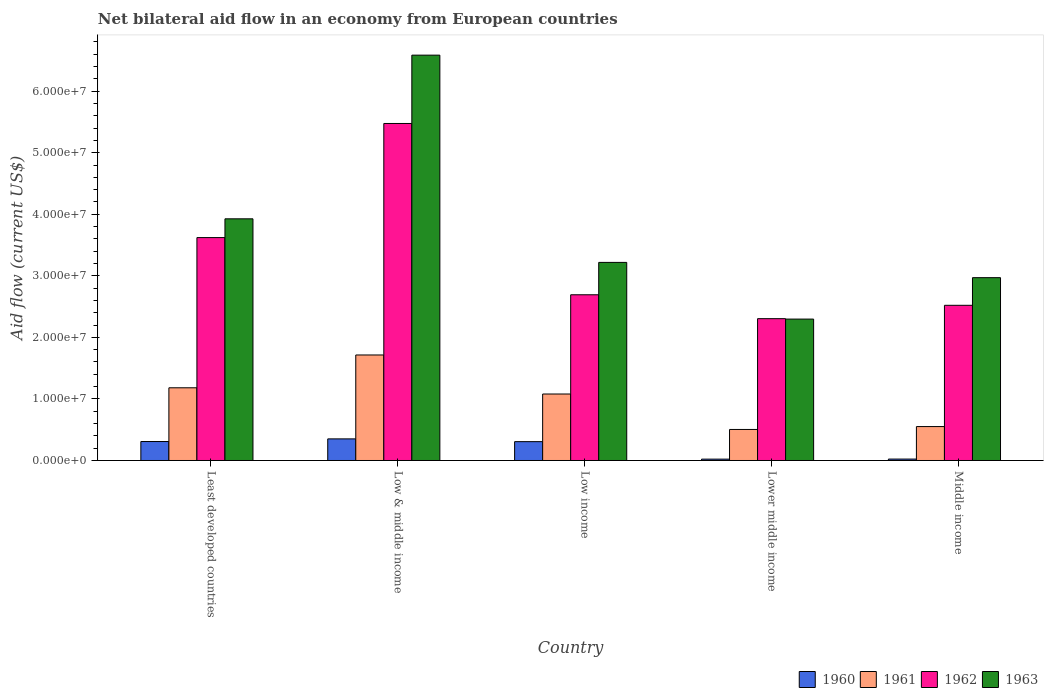Are the number of bars on each tick of the X-axis equal?
Ensure brevity in your answer.  Yes. How many bars are there on the 2nd tick from the right?
Your answer should be very brief. 4. In how many cases, is the number of bars for a given country not equal to the number of legend labels?
Ensure brevity in your answer.  0. What is the net bilateral aid flow in 1960 in Middle income?
Your answer should be compact. 2.30e+05. Across all countries, what is the maximum net bilateral aid flow in 1961?
Your response must be concise. 1.71e+07. Across all countries, what is the minimum net bilateral aid flow in 1962?
Your response must be concise. 2.30e+07. In which country was the net bilateral aid flow in 1960 maximum?
Give a very brief answer. Low & middle income. In which country was the net bilateral aid flow in 1962 minimum?
Keep it short and to the point. Lower middle income. What is the total net bilateral aid flow in 1960 in the graph?
Keep it short and to the point. 1.01e+07. What is the difference between the net bilateral aid flow in 1962 in Low income and the net bilateral aid flow in 1960 in Least developed countries?
Make the answer very short. 2.38e+07. What is the average net bilateral aid flow in 1961 per country?
Your response must be concise. 1.01e+07. What is the difference between the net bilateral aid flow of/in 1963 and net bilateral aid flow of/in 1960 in Low income?
Ensure brevity in your answer.  2.91e+07. In how many countries, is the net bilateral aid flow in 1961 greater than 2000000 US$?
Make the answer very short. 5. What is the ratio of the net bilateral aid flow in 1962 in Low & middle income to that in Lower middle income?
Your answer should be compact. 2.38. Is the net bilateral aid flow in 1960 in Least developed countries less than that in Middle income?
Your answer should be compact. No. Is the difference between the net bilateral aid flow in 1963 in Low income and Lower middle income greater than the difference between the net bilateral aid flow in 1960 in Low income and Lower middle income?
Keep it short and to the point. Yes. What is the difference between the highest and the second highest net bilateral aid flow in 1962?
Make the answer very short. 2.78e+07. What is the difference between the highest and the lowest net bilateral aid flow in 1963?
Keep it short and to the point. 4.29e+07. Is the sum of the net bilateral aid flow in 1960 in Least developed countries and Middle income greater than the maximum net bilateral aid flow in 1962 across all countries?
Ensure brevity in your answer.  No. Is it the case that in every country, the sum of the net bilateral aid flow in 1960 and net bilateral aid flow in 1963 is greater than the sum of net bilateral aid flow in 1961 and net bilateral aid flow in 1962?
Ensure brevity in your answer.  Yes. What does the 3rd bar from the left in Least developed countries represents?
Your answer should be very brief. 1962. What does the 1st bar from the right in Lower middle income represents?
Provide a short and direct response. 1963. Is it the case that in every country, the sum of the net bilateral aid flow in 1963 and net bilateral aid flow in 1962 is greater than the net bilateral aid flow in 1960?
Offer a very short reply. Yes. Are all the bars in the graph horizontal?
Ensure brevity in your answer.  No. What is the difference between two consecutive major ticks on the Y-axis?
Keep it short and to the point. 1.00e+07. How many legend labels are there?
Give a very brief answer. 4. How are the legend labels stacked?
Provide a short and direct response. Horizontal. What is the title of the graph?
Offer a terse response. Net bilateral aid flow in an economy from European countries. What is the label or title of the X-axis?
Provide a short and direct response. Country. What is the label or title of the Y-axis?
Your answer should be compact. Aid flow (current US$). What is the Aid flow (current US$) of 1960 in Least developed countries?
Provide a succinct answer. 3.08e+06. What is the Aid flow (current US$) in 1961 in Least developed countries?
Keep it short and to the point. 1.18e+07. What is the Aid flow (current US$) in 1962 in Least developed countries?
Your answer should be compact. 3.62e+07. What is the Aid flow (current US$) in 1963 in Least developed countries?
Provide a succinct answer. 3.93e+07. What is the Aid flow (current US$) in 1960 in Low & middle income?
Ensure brevity in your answer.  3.51e+06. What is the Aid flow (current US$) of 1961 in Low & middle income?
Your answer should be compact. 1.71e+07. What is the Aid flow (current US$) in 1962 in Low & middle income?
Offer a terse response. 5.48e+07. What is the Aid flow (current US$) of 1963 in Low & middle income?
Provide a succinct answer. 6.58e+07. What is the Aid flow (current US$) in 1960 in Low income?
Offer a terse response. 3.06e+06. What is the Aid flow (current US$) of 1961 in Low income?
Ensure brevity in your answer.  1.08e+07. What is the Aid flow (current US$) of 1962 in Low income?
Make the answer very short. 2.69e+07. What is the Aid flow (current US$) of 1963 in Low income?
Offer a very short reply. 3.22e+07. What is the Aid flow (current US$) of 1960 in Lower middle income?
Your answer should be compact. 2.20e+05. What is the Aid flow (current US$) in 1961 in Lower middle income?
Ensure brevity in your answer.  5.04e+06. What is the Aid flow (current US$) of 1962 in Lower middle income?
Ensure brevity in your answer.  2.30e+07. What is the Aid flow (current US$) of 1963 in Lower middle income?
Provide a succinct answer. 2.30e+07. What is the Aid flow (current US$) in 1960 in Middle income?
Make the answer very short. 2.30e+05. What is the Aid flow (current US$) in 1961 in Middle income?
Ensure brevity in your answer.  5.51e+06. What is the Aid flow (current US$) of 1962 in Middle income?
Your response must be concise. 2.52e+07. What is the Aid flow (current US$) of 1963 in Middle income?
Your response must be concise. 2.97e+07. Across all countries, what is the maximum Aid flow (current US$) in 1960?
Provide a succinct answer. 3.51e+06. Across all countries, what is the maximum Aid flow (current US$) of 1961?
Keep it short and to the point. 1.71e+07. Across all countries, what is the maximum Aid flow (current US$) of 1962?
Ensure brevity in your answer.  5.48e+07. Across all countries, what is the maximum Aid flow (current US$) in 1963?
Your response must be concise. 6.58e+07. Across all countries, what is the minimum Aid flow (current US$) of 1961?
Ensure brevity in your answer.  5.04e+06. Across all countries, what is the minimum Aid flow (current US$) of 1962?
Offer a very short reply. 2.30e+07. Across all countries, what is the minimum Aid flow (current US$) in 1963?
Provide a succinct answer. 2.30e+07. What is the total Aid flow (current US$) of 1960 in the graph?
Make the answer very short. 1.01e+07. What is the total Aid flow (current US$) of 1961 in the graph?
Ensure brevity in your answer.  5.03e+07. What is the total Aid flow (current US$) in 1962 in the graph?
Provide a short and direct response. 1.66e+08. What is the total Aid flow (current US$) of 1963 in the graph?
Your answer should be compact. 1.90e+08. What is the difference between the Aid flow (current US$) of 1960 in Least developed countries and that in Low & middle income?
Give a very brief answer. -4.30e+05. What is the difference between the Aid flow (current US$) of 1961 in Least developed countries and that in Low & middle income?
Provide a short and direct response. -5.33e+06. What is the difference between the Aid flow (current US$) of 1962 in Least developed countries and that in Low & middle income?
Provide a succinct answer. -1.85e+07. What is the difference between the Aid flow (current US$) in 1963 in Least developed countries and that in Low & middle income?
Give a very brief answer. -2.66e+07. What is the difference between the Aid flow (current US$) in 1961 in Least developed countries and that in Low income?
Keep it short and to the point. 1.01e+06. What is the difference between the Aid flow (current US$) of 1962 in Least developed countries and that in Low income?
Make the answer very short. 9.29e+06. What is the difference between the Aid flow (current US$) of 1963 in Least developed countries and that in Low income?
Ensure brevity in your answer.  7.08e+06. What is the difference between the Aid flow (current US$) of 1960 in Least developed countries and that in Lower middle income?
Make the answer very short. 2.86e+06. What is the difference between the Aid flow (current US$) in 1961 in Least developed countries and that in Lower middle income?
Make the answer very short. 6.77e+06. What is the difference between the Aid flow (current US$) in 1962 in Least developed countries and that in Lower middle income?
Keep it short and to the point. 1.32e+07. What is the difference between the Aid flow (current US$) in 1963 in Least developed countries and that in Lower middle income?
Provide a short and direct response. 1.63e+07. What is the difference between the Aid flow (current US$) of 1960 in Least developed countries and that in Middle income?
Your answer should be compact. 2.85e+06. What is the difference between the Aid flow (current US$) of 1961 in Least developed countries and that in Middle income?
Offer a terse response. 6.30e+06. What is the difference between the Aid flow (current US$) in 1962 in Least developed countries and that in Middle income?
Your answer should be very brief. 1.10e+07. What is the difference between the Aid flow (current US$) of 1963 in Least developed countries and that in Middle income?
Your answer should be very brief. 9.56e+06. What is the difference between the Aid flow (current US$) of 1960 in Low & middle income and that in Low income?
Provide a succinct answer. 4.50e+05. What is the difference between the Aid flow (current US$) of 1961 in Low & middle income and that in Low income?
Keep it short and to the point. 6.34e+06. What is the difference between the Aid flow (current US$) of 1962 in Low & middle income and that in Low income?
Your answer should be compact. 2.78e+07. What is the difference between the Aid flow (current US$) in 1963 in Low & middle income and that in Low income?
Your response must be concise. 3.37e+07. What is the difference between the Aid flow (current US$) of 1960 in Low & middle income and that in Lower middle income?
Make the answer very short. 3.29e+06. What is the difference between the Aid flow (current US$) in 1961 in Low & middle income and that in Lower middle income?
Your answer should be compact. 1.21e+07. What is the difference between the Aid flow (current US$) of 1962 in Low & middle income and that in Lower middle income?
Ensure brevity in your answer.  3.17e+07. What is the difference between the Aid flow (current US$) in 1963 in Low & middle income and that in Lower middle income?
Make the answer very short. 4.29e+07. What is the difference between the Aid flow (current US$) in 1960 in Low & middle income and that in Middle income?
Provide a short and direct response. 3.28e+06. What is the difference between the Aid flow (current US$) in 1961 in Low & middle income and that in Middle income?
Provide a short and direct response. 1.16e+07. What is the difference between the Aid flow (current US$) of 1962 in Low & middle income and that in Middle income?
Keep it short and to the point. 2.95e+07. What is the difference between the Aid flow (current US$) in 1963 in Low & middle income and that in Middle income?
Your answer should be compact. 3.62e+07. What is the difference between the Aid flow (current US$) of 1960 in Low income and that in Lower middle income?
Your response must be concise. 2.84e+06. What is the difference between the Aid flow (current US$) of 1961 in Low income and that in Lower middle income?
Your response must be concise. 5.76e+06. What is the difference between the Aid flow (current US$) of 1962 in Low income and that in Lower middle income?
Provide a succinct answer. 3.88e+06. What is the difference between the Aid flow (current US$) of 1963 in Low income and that in Lower middle income?
Provide a short and direct response. 9.21e+06. What is the difference between the Aid flow (current US$) in 1960 in Low income and that in Middle income?
Offer a terse response. 2.83e+06. What is the difference between the Aid flow (current US$) of 1961 in Low income and that in Middle income?
Provide a succinct answer. 5.29e+06. What is the difference between the Aid flow (current US$) in 1962 in Low income and that in Middle income?
Offer a terse response. 1.71e+06. What is the difference between the Aid flow (current US$) in 1963 in Low income and that in Middle income?
Keep it short and to the point. 2.48e+06. What is the difference between the Aid flow (current US$) of 1960 in Lower middle income and that in Middle income?
Give a very brief answer. -10000. What is the difference between the Aid flow (current US$) in 1961 in Lower middle income and that in Middle income?
Your response must be concise. -4.70e+05. What is the difference between the Aid flow (current US$) in 1962 in Lower middle income and that in Middle income?
Offer a very short reply. -2.17e+06. What is the difference between the Aid flow (current US$) of 1963 in Lower middle income and that in Middle income?
Ensure brevity in your answer.  -6.73e+06. What is the difference between the Aid flow (current US$) of 1960 in Least developed countries and the Aid flow (current US$) of 1961 in Low & middle income?
Your answer should be compact. -1.41e+07. What is the difference between the Aid flow (current US$) of 1960 in Least developed countries and the Aid flow (current US$) of 1962 in Low & middle income?
Offer a terse response. -5.17e+07. What is the difference between the Aid flow (current US$) of 1960 in Least developed countries and the Aid flow (current US$) of 1963 in Low & middle income?
Keep it short and to the point. -6.28e+07. What is the difference between the Aid flow (current US$) in 1961 in Least developed countries and the Aid flow (current US$) in 1962 in Low & middle income?
Offer a very short reply. -4.29e+07. What is the difference between the Aid flow (current US$) in 1961 in Least developed countries and the Aid flow (current US$) in 1963 in Low & middle income?
Offer a terse response. -5.40e+07. What is the difference between the Aid flow (current US$) in 1962 in Least developed countries and the Aid flow (current US$) in 1963 in Low & middle income?
Offer a terse response. -2.96e+07. What is the difference between the Aid flow (current US$) in 1960 in Least developed countries and the Aid flow (current US$) in 1961 in Low income?
Provide a succinct answer. -7.72e+06. What is the difference between the Aid flow (current US$) of 1960 in Least developed countries and the Aid flow (current US$) of 1962 in Low income?
Your answer should be compact. -2.38e+07. What is the difference between the Aid flow (current US$) in 1960 in Least developed countries and the Aid flow (current US$) in 1963 in Low income?
Offer a terse response. -2.91e+07. What is the difference between the Aid flow (current US$) of 1961 in Least developed countries and the Aid flow (current US$) of 1962 in Low income?
Ensure brevity in your answer.  -1.51e+07. What is the difference between the Aid flow (current US$) of 1961 in Least developed countries and the Aid flow (current US$) of 1963 in Low income?
Your response must be concise. -2.04e+07. What is the difference between the Aid flow (current US$) in 1962 in Least developed countries and the Aid flow (current US$) in 1963 in Low income?
Provide a succinct answer. 4.03e+06. What is the difference between the Aid flow (current US$) of 1960 in Least developed countries and the Aid flow (current US$) of 1961 in Lower middle income?
Your answer should be compact. -1.96e+06. What is the difference between the Aid flow (current US$) of 1960 in Least developed countries and the Aid flow (current US$) of 1962 in Lower middle income?
Offer a very short reply. -2.00e+07. What is the difference between the Aid flow (current US$) in 1960 in Least developed countries and the Aid flow (current US$) in 1963 in Lower middle income?
Provide a succinct answer. -1.99e+07. What is the difference between the Aid flow (current US$) of 1961 in Least developed countries and the Aid flow (current US$) of 1962 in Lower middle income?
Your answer should be compact. -1.12e+07. What is the difference between the Aid flow (current US$) in 1961 in Least developed countries and the Aid flow (current US$) in 1963 in Lower middle income?
Provide a short and direct response. -1.12e+07. What is the difference between the Aid flow (current US$) of 1962 in Least developed countries and the Aid flow (current US$) of 1963 in Lower middle income?
Give a very brief answer. 1.32e+07. What is the difference between the Aid flow (current US$) of 1960 in Least developed countries and the Aid flow (current US$) of 1961 in Middle income?
Provide a short and direct response. -2.43e+06. What is the difference between the Aid flow (current US$) in 1960 in Least developed countries and the Aid flow (current US$) in 1962 in Middle income?
Provide a short and direct response. -2.21e+07. What is the difference between the Aid flow (current US$) of 1960 in Least developed countries and the Aid flow (current US$) of 1963 in Middle income?
Provide a succinct answer. -2.66e+07. What is the difference between the Aid flow (current US$) in 1961 in Least developed countries and the Aid flow (current US$) in 1962 in Middle income?
Provide a succinct answer. -1.34e+07. What is the difference between the Aid flow (current US$) in 1961 in Least developed countries and the Aid flow (current US$) in 1963 in Middle income?
Your answer should be very brief. -1.79e+07. What is the difference between the Aid flow (current US$) of 1962 in Least developed countries and the Aid flow (current US$) of 1963 in Middle income?
Provide a succinct answer. 6.51e+06. What is the difference between the Aid flow (current US$) in 1960 in Low & middle income and the Aid flow (current US$) in 1961 in Low income?
Your answer should be very brief. -7.29e+06. What is the difference between the Aid flow (current US$) in 1960 in Low & middle income and the Aid flow (current US$) in 1962 in Low income?
Provide a succinct answer. -2.34e+07. What is the difference between the Aid flow (current US$) of 1960 in Low & middle income and the Aid flow (current US$) of 1963 in Low income?
Give a very brief answer. -2.87e+07. What is the difference between the Aid flow (current US$) in 1961 in Low & middle income and the Aid flow (current US$) in 1962 in Low income?
Give a very brief answer. -9.78e+06. What is the difference between the Aid flow (current US$) of 1961 in Low & middle income and the Aid flow (current US$) of 1963 in Low income?
Offer a terse response. -1.50e+07. What is the difference between the Aid flow (current US$) in 1962 in Low & middle income and the Aid flow (current US$) in 1963 in Low income?
Offer a very short reply. 2.26e+07. What is the difference between the Aid flow (current US$) in 1960 in Low & middle income and the Aid flow (current US$) in 1961 in Lower middle income?
Offer a terse response. -1.53e+06. What is the difference between the Aid flow (current US$) in 1960 in Low & middle income and the Aid flow (current US$) in 1962 in Lower middle income?
Ensure brevity in your answer.  -1.95e+07. What is the difference between the Aid flow (current US$) in 1960 in Low & middle income and the Aid flow (current US$) in 1963 in Lower middle income?
Make the answer very short. -1.95e+07. What is the difference between the Aid flow (current US$) in 1961 in Low & middle income and the Aid flow (current US$) in 1962 in Lower middle income?
Your response must be concise. -5.90e+06. What is the difference between the Aid flow (current US$) of 1961 in Low & middle income and the Aid flow (current US$) of 1963 in Lower middle income?
Make the answer very short. -5.83e+06. What is the difference between the Aid flow (current US$) in 1962 in Low & middle income and the Aid flow (current US$) in 1963 in Lower middle income?
Provide a short and direct response. 3.18e+07. What is the difference between the Aid flow (current US$) in 1960 in Low & middle income and the Aid flow (current US$) in 1961 in Middle income?
Your answer should be very brief. -2.00e+06. What is the difference between the Aid flow (current US$) of 1960 in Low & middle income and the Aid flow (current US$) of 1962 in Middle income?
Your response must be concise. -2.17e+07. What is the difference between the Aid flow (current US$) in 1960 in Low & middle income and the Aid flow (current US$) in 1963 in Middle income?
Offer a terse response. -2.62e+07. What is the difference between the Aid flow (current US$) of 1961 in Low & middle income and the Aid flow (current US$) of 1962 in Middle income?
Ensure brevity in your answer.  -8.07e+06. What is the difference between the Aid flow (current US$) in 1961 in Low & middle income and the Aid flow (current US$) in 1963 in Middle income?
Your response must be concise. -1.26e+07. What is the difference between the Aid flow (current US$) of 1962 in Low & middle income and the Aid flow (current US$) of 1963 in Middle income?
Your answer should be very brief. 2.50e+07. What is the difference between the Aid flow (current US$) in 1960 in Low income and the Aid flow (current US$) in 1961 in Lower middle income?
Ensure brevity in your answer.  -1.98e+06. What is the difference between the Aid flow (current US$) of 1960 in Low income and the Aid flow (current US$) of 1962 in Lower middle income?
Offer a terse response. -2.00e+07. What is the difference between the Aid flow (current US$) in 1960 in Low income and the Aid flow (current US$) in 1963 in Lower middle income?
Your response must be concise. -1.99e+07. What is the difference between the Aid flow (current US$) of 1961 in Low income and the Aid flow (current US$) of 1962 in Lower middle income?
Ensure brevity in your answer.  -1.22e+07. What is the difference between the Aid flow (current US$) of 1961 in Low income and the Aid flow (current US$) of 1963 in Lower middle income?
Make the answer very short. -1.22e+07. What is the difference between the Aid flow (current US$) of 1962 in Low income and the Aid flow (current US$) of 1963 in Lower middle income?
Ensure brevity in your answer.  3.95e+06. What is the difference between the Aid flow (current US$) in 1960 in Low income and the Aid flow (current US$) in 1961 in Middle income?
Ensure brevity in your answer.  -2.45e+06. What is the difference between the Aid flow (current US$) of 1960 in Low income and the Aid flow (current US$) of 1962 in Middle income?
Your response must be concise. -2.22e+07. What is the difference between the Aid flow (current US$) of 1960 in Low income and the Aid flow (current US$) of 1963 in Middle income?
Provide a short and direct response. -2.66e+07. What is the difference between the Aid flow (current US$) of 1961 in Low income and the Aid flow (current US$) of 1962 in Middle income?
Your response must be concise. -1.44e+07. What is the difference between the Aid flow (current US$) in 1961 in Low income and the Aid flow (current US$) in 1963 in Middle income?
Provide a succinct answer. -1.89e+07. What is the difference between the Aid flow (current US$) in 1962 in Low income and the Aid flow (current US$) in 1963 in Middle income?
Make the answer very short. -2.78e+06. What is the difference between the Aid flow (current US$) of 1960 in Lower middle income and the Aid flow (current US$) of 1961 in Middle income?
Provide a short and direct response. -5.29e+06. What is the difference between the Aid flow (current US$) in 1960 in Lower middle income and the Aid flow (current US$) in 1962 in Middle income?
Provide a succinct answer. -2.50e+07. What is the difference between the Aid flow (current US$) of 1960 in Lower middle income and the Aid flow (current US$) of 1963 in Middle income?
Your answer should be compact. -2.95e+07. What is the difference between the Aid flow (current US$) of 1961 in Lower middle income and the Aid flow (current US$) of 1962 in Middle income?
Your answer should be compact. -2.02e+07. What is the difference between the Aid flow (current US$) of 1961 in Lower middle income and the Aid flow (current US$) of 1963 in Middle income?
Offer a terse response. -2.47e+07. What is the difference between the Aid flow (current US$) in 1962 in Lower middle income and the Aid flow (current US$) in 1963 in Middle income?
Offer a very short reply. -6.66e+06. What is the average Aid flow (current US$) of 1960 per country?
Provide a succinct answer. 2.02e+06. What is the average Aid flow (current US$) of 1961 per country?
Provide a short and direct response. 1.01e+07. What is the average Aid flow (current US$) of 1962 per country?
Ensure brevity in your answer.  3.32e+07. What is the average Aid flow (current US$) in 1963 per country?
Ensure brevity in your answer.  3.80e+07. What is the difference between the Aid flow (current US$) of 1960 and Aid flow (current US$) of 1961 in Least developed countries?
Your answer should be compact. -8.73e+06. What is the difference between the Aid flow (current US$) of 1960 and Aid flow (current US$) of 1962 in Least developed countries?
Provide a succinct answer. -3.31e+07. What is the difference between the Aid flow (current US$) of 1960 and Aid flow (current US$) of 1963 in Least developed countries?
Offer a terse response. -3.62e+07. What is the difference between the Aid flow (current US$) in 1961 and Aid flow (current US$) in 1962 in Least developed countries?
Your response must be concise. -2.44e+07. What is the difference between the Aid flow (current US$) of 1961 and Aid flow (current US$) of 1963 in Least developed countries?
Give a very brief answer. -2.74e+07. What is the difference between the Aid flow (current US$) in 1962 and Aid flow (current US$) in 1963 in Least developed countries?
Make the answer very short. -3.05e+06. What is the difference between the Aid flow (current US$) of 1960 and Aid flow (current US$) of 1961 in Low & middle income?
Keep it short and to the point. -1.36e+07. What is the difference between the Aid flow (current US$) of 1960 and Aid flow (current US$) of 1962 in Low & middle income?
Ensure brevity in your answer.  -5.12e+07. What is the difference between the Aid flow (current US$) of 1960 and Aid flow (current US$) of 1963 in Low & middle income?
Ensure brevity in your answer.  -6.23e+07. What is the difference between the Aid flow (current US$) in 1961 and Aid flow (current US$) in 1962 in Low & middle income?
Your answer should be compact. -3.76e+07. What is the difference between the Aid flow (current US$) in 1961 and Aid flow (current US$) in 1963 in Low & middle income?
Your answer should be very brief. -4.87e+07. What is the difference between the Aid flow (current US$) of 1962 and Aid flow (current US$) of 1963 in Low & middle income?
Offer a very short reply. -1.11e+07. What is the difference between the Aid flow (current US$) of 1960 and Aid flow (current US$) of 1961 in Low income?
Give a very brief answer. -7.74e+06. What is the difference between the Aid flow (current US$) in 1960 and Aid flow (current US$) in 1962 in Low income?
Provide a short and direct response. -2.39e+07. What is the difference between the Aid flow (current US$) of 1960 and Aid flow (current US$) of 1963 in Low income?
Your response must be concise. -2.91e+07. What is the difference between the Aid flow (current US$) in 1961 and Aid flow (current US$) in 1962 in Low income?
Make the answer very short. -1.61e+07. What is the difference between the Aid flow (current US$) in 1961 and Aid flow (current US$) in 1963 in Low income?
Your response must be concise. -2.14e+07. What is the difference between the Aid flow (current US$) of 1962 and Aid flow (current US$) of 1963 in Low income?
Your answer should be compact. -5.26e+06. What is the difference between the Aid flow (current US$) in 1960 and Aid flow (current US$) in 1961 in Lower middle income?
Give a very brief answer. -4.82e+06. What is the difference between the Aid flow (current US$) in 1960 and Aid flow (current US$) in 1962 in Lower middle income?
Your response must be concise. -2.28e+07. What is the difference between the Aid flow (current US$) of 1960 and Aid flow (current US$) of 1963 in Lower middle income?
Ensure brevity in your answer.  -2.28e+07. What is the difference between the Aid flow (current US$) of 1961 and Aid flow (current US$) of 1962 in Lower middle income?
Keep it short and to the point. -1.80e+07. What is the difference between the Aid flow (current US$) in 1961 and Aid flow (current US$) in 1963 in Lower middle income?
Offer a very short reply. -1.79e+07. What is the difference between the Aid flow (current US$) of 1962 and Aid flow (current US$) of 1963 in Lower middle income?
Make the answer very short. 7.00e+04. What is the difference between the Aid flow (current US$) in 1960 and Aid flow (current US$) in 1961 in Middle income?
Provide a short and direct response. -5.28e+06. What is the difference between the Aid flow (current US$) in 1960 and Aid flow (current US$) in 1962 in Middle income?
Provide a short and direct response. -2.50e+07. What is the difference between the Aid flow (current US$) of 1960 and Aid flow (current US$) of 1963 in Middle income?
Provide a succinct answer. -2.95e+07. What is the difference between the Aid flow (current US$) of 1961 and Aid flow (current US$) of 1962 in Middle income?
Ensure brevity in your answer.  -1.97e+07. What is the difference between the Aid flow (current US$) in 1961 and Aid flow (current US$) in 1963 in Middle income?
Provide a succinct answer. -2.42e+07. What is the difference between the Aid flow (current US$) of 1962 and Aid flow (current US$) of 1963 in Middle income?
Keep it short and to the point. -4.49e+06. What is the ratio of the Aid flow (current US$) in 1960 in Least developed countries to that in Low & middle income?
Ensure brevity in your answer.  0.88. What is the ratio of the Aid flow (current US$) in 1961 in Least developed countries to that in Low & middle income?
Provide a succinct answer. 0.69. What is the ratio of the Aid flow (current US$) in 1962 in Least developed countries to that in Low & middle income?
Your answer should be compact. 0.66. What is the ratio of the Aid flow (current US$) in 1963 in Least developed countries to that in Low & middle income?
Give a very brief answer. 0.6. What is the ratio of the Aid flow (current US$) in 1961 in Least developed countries to that in Low income?
Make the answer very short. 1.09. What is the ratio of the Aid flow (current US$) in 1962 in Least developed countries to that in Low income?
Your answer should be very brief. 1.35. What is the ratio of the Aid flow (current US$) of 1963 in Least developed countries to that in Low income?
Your answer should be compact. 1.22. What is the ratio of the Aid flow (current US$) of 1961 in Least developed countries to that in Lower middle income?
Your answer should be very brief. 2.34. What is the ratio of the Aid flow (current US$) of 1962 in Least developed countries to that in Lower middle income?
Your response must be concise. 1.57. What is the ratio of the Aid flow (current US$) of 1963 in Least developed countries to that in Lower middle income?
Make the answer very short. 1.71. What is the ratio of the Aid flow (current US$) of 1960 in Least developed countries to that in Middle income?
Your answer should be compact. 13.39. What is the ratio of the Aid flow (current US$) of 1961 in Least developed countries to that in Middle income?
Your answer should be very brief. 2.14. What is the ratio of the Aid flow (current US$) of 1962 in Least developed countries to that in Middle income?
Ensure brevity in your answer.  1.44. What is the ratio of the Aid flow (current US$) in 1963 in Least developed countries to that in Middle income?
Make the answer very short. 1.32. What is the ratio of the Aid flow (current US$) in 1960 in Low & middle income to that in Low income?
Your answer should be compact. 1.15. What is the ratio of the Aid flow (current US$) of 1961 in Low & middle income to that in Low income?
Provide a succinct answer. 1.59. What is the ratio of the Aid flow (current US$) in 1962 in Low & middle income to that in Low income?
Your answer should be compact. 2.03. What is the ratio of the Aid flow (current US$) of 1963 in Low & middle income to that in Low income?
Make the answer very short. 2.05. What is the ratio of the Aid flow (current US$) of 1960 in Low & middle income to that in Lower middle income?
Make the answer very short. 15.95. What is the ratio of the Aid flow (current US$) in 1961 in Low & middle income to that in Lower middle income?
Provide a short and direct response. 3.4. What is the ratio of the Aid flow (current US$) in 1962 in Low & middle income to that in Lower middle income?
Give a very brief answer. 2.38. What is the ratio of the Aid flow (current US$) in 1963 in Low & middle income to that in Lower middle income?
Keep it short and to the point. 2.87. What is the ratio of the Aid flow (current US$) of 1960 in Low & middle income to that in Middle income?
Your answer should be very brief. 15.26. What is the ratio of the Aid flow (current US$) of 1961 in Low & middle income to that in Middle income?
Make the answer very short. 3.11. What is the ratio of the Aid flow (current US$) in 1962 in Low & middle income to that in Middle income?
Keep it short and to the point. 2.17. What is the ratio of the Aid flow (current US$) in 1963 in Low & middle income to that in Middle income?
Give a very brief answer. 2.22. What is the ratio of the Aid flow (current US$) in 1960 in Low income to that in Lower middle income?
Your response must be concise. 13.91. What is the ratio of the Aid flow (current US$) of 1961 in Low income to that in Lower middle income?
Your response must be concise. 2.14. What is the ratio of the Aid flow (current US$) of 1962 in Low income to that in Lower middle income?
Your response must be concise. 1.17. What is the ratio of the Aid flow (current US$) of 1963 in Low income to that in Lower middle income?
Your response must be concise. 1.4. What is the ratio of the Aid flow (current US$) in 1960 in Low income to that in Middle income?
Ensure brevity in your answer.  13.3. What is the ratio of the Aid flow (current US$) of 1961 in Low income to that in Middle income?
Provide a short and direct response. 1.96. What is the ratio of the Aid flow (current US$) in 1962 in Low income to that in Middle income?
Provide a succinct answer. 1.07. What is the ratio of the Aid flow (current US$) in 1963 in Low income to that in Middle income?
Make the answer very short. 1.08. What is the ratio of the Aid flow (current US$) of 1960 in Lower middle income to that in Middle income?
Offer a terse response. 0.96. What is the ratio of the Aid flow (current US$) of 1961 in Lower middle income to that in Middle income?
Give a very brief answer. 0.91. What is the ratio of the Aid flow (current US$) of 1962 in Lower middle income to that in Middle income?
Your answer should be very brief. 0.91. What is the ratio of the Aid flow (current US$) of 1963 in Lower middle income to that in Middle income?
Keep it short and to the point. 0.77. What is the difference between the highest and the second highest Aid flow (current US$) in 1961?
Your response must be concise. 5.33e+06. What is the difference between the highest and the second highest Aid flow (current US$) of 1962?
Keep it short and to the point. 1.85e+07. What is the difference between the highest and the second highest Aid flow (current US$) in 1963?
Give a very brief answer. 2.66e+07. What is the difference between the highest and the lowest Aid flow (current US$) of 1960?
Provide a short and direct response. 3.29e+06. What is the difference between the highest and the lowest Aid flow (current US$) in 1961?
Your answer should be very brief. 1.21e+07. What is the difference between the highest and the lowest Aid flow (current US$) of 1962?
Make the answer very short. 3.17e+07. What is the difference between the highest and the lowest Aid flow (current US$) in 1963?
Your response must be concise. 4.29e+07. 